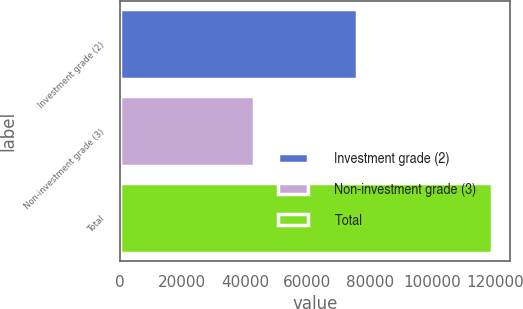<chart> <loc_0><loc_0><loc_500><loc_500><bar_chart><fcel>Investment grade (2)<fcel>Non-investment grade (3)<fcel>Total<nl><fcel>75848<fcel>42960<fcel>118808<nl></chart> 